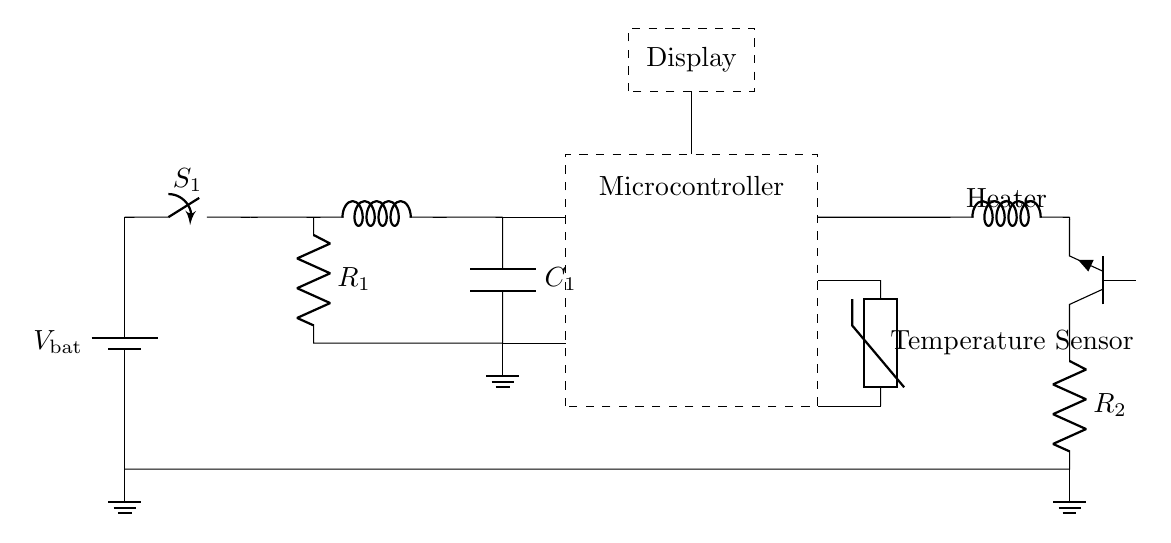What is the main purpose of the temperature sensor? The temperature sensor is used to monitor the temperature of the cupcakes to ensure they stay fresh. It provides data to the microcontroller, which regulates the heating based on the sensed temperature.
Answer: Monitor temperature What type of component is the large rectangle labeled "Microcontroller"? The microcontroller is a programmable component used to process input from the temperature sensor and control the heater based on that data. Its presence indicates that the circuit has intelligent control capabilities.
Answer: Programmable component What does the switch labeled "S1" control? The switch controls the power supply to the circuit, allowing the user to turn the entire system on or off. It is the first point of control in the power path from the battery to the rest of the circuit.
Answer: Power supply What is the role of the resistor labeled "R1"? Resistor R1 is connected in the circuit to limit the current flowing to the microcontroller, ensuring it operates within safe limits. This component helps protect the microcontroller from damage due to excessive current.
Answer: Limit current How does the heater get activated in this circuit? The heater is activated by the output from the microcontroller, which controls the Tnpn transistor. When the temperature falls below a certain threshold, the microcontroller signals the transistor to turn on the heater, warming the cupcakes.
Answer: Through microcontroller control What voltage does the battery supply in this circuit? The battery provides a potential difference necessary to power the entire circuit; while the specific voltage is not detailed in the diagram, it can be inferred that a standard battery voltage is used, typically 5 or 12 volts.
Answer: Battery voltage What is the purpose of the capacitor labeled "C1"? Capacitor C1 serves to smooth out voltage fluctuations by storing and releasing electrical energy, which stabilizes the power supply to the components, particularly the microcontroller. This ensures steady operation of the circuit.
Answer: Smooth voltage 